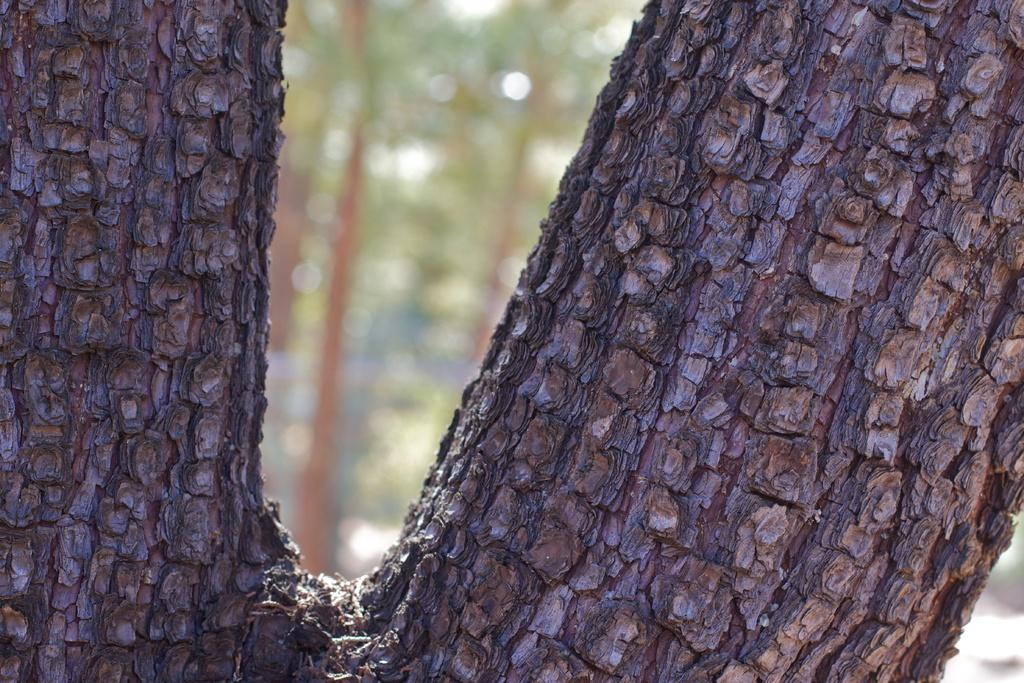What is the main subject in the foreground of the image? The trunk of a tree is visible in the foreground of the image. How would you describe the background of the image? The background of the image is blurred. What type of vegetation can be seen in the background of the image? There is greenery in the background of the image. What type of quartz can be seen in the image? There is no quartz present in the image. What rule is being followed by the tree in the image? Trees do not follow rules; they grow and develop based on natural processes. 